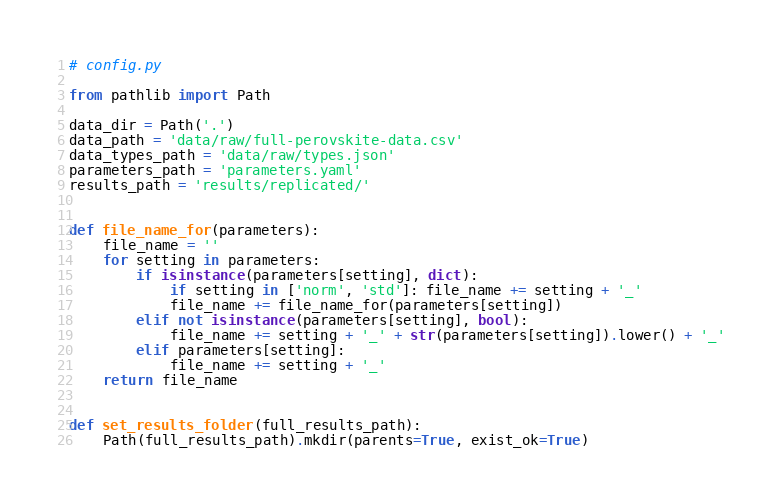Convert code to text. <code><loc_0><loc_0><loc_500><loc_500><_Python_># config.py

from pathlib import Path

data_dir = Path('.')
data_path = 'data/raw/full-perovskite-data.csv' 
data_types_path = 'data/raw/types.json'
parameters_path = 'parameters.yaml'
results_path = 'results/replicated/'


def file_name_for(parameters):
    file_name = ''
    for setting in parameters:
        if isinstance(parameters[setting], dict):
            if setting in ['norm', 'std']: file_name += setting + '_'
            file_name += file_name_for(parameters[setting])
        elif not isinstance(parameters[setting], bool):
            file_name += setting + '_' + str(parameters[setting]).lower() + '_'
        elif parameters[setting]:
            file_name += setting + '_'
    return file_name


def set_results_folder(full_results_path):
    Path(full_results_path).mkdir(parents=True, exist_ok=True)

</code> 